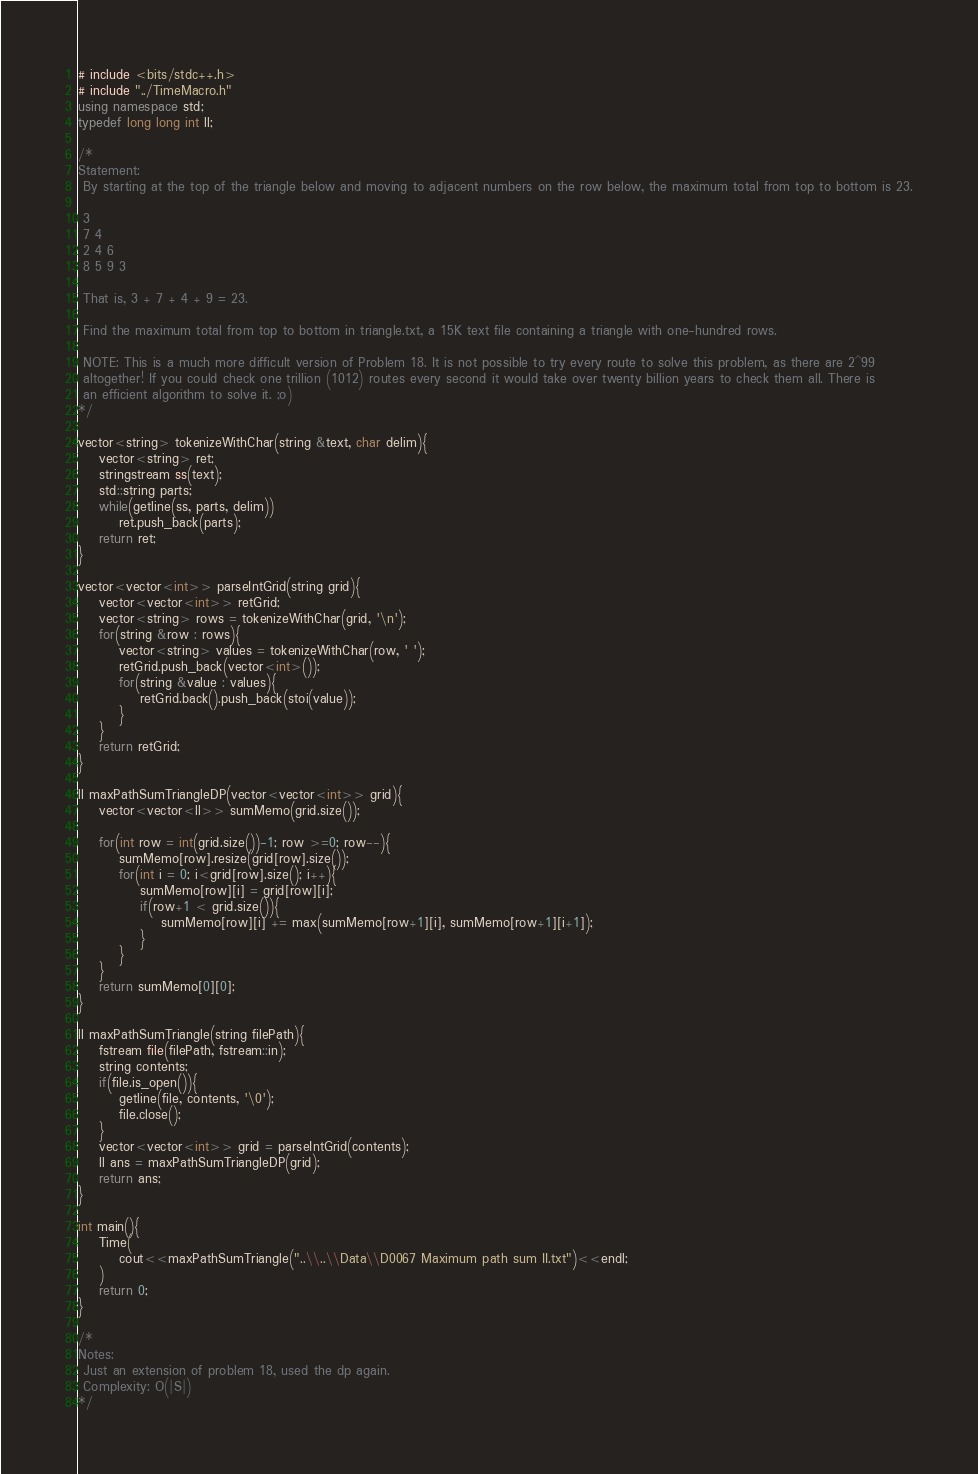<code> <loc_0><loc_0><loc_500><loc_500><_C++_># include <bits/stdc++.h>
# include "../TimeMacro.h"
using namespace std;
typedef long long int ll;

/*
Statement:
 By starting at the top of the triangle below and moving to adjacent numbers on the row below, the maximum total from top to bottom is 23.
 
 3
 7 4
 2 4 6
 8 5 9 3
 
 That is, 3 + 7 + 4 + 9 = 23.
 
 Find the maximum total from top to bottom in triangle.txt, a 15K text file containing a triangle with one-hundred rows.
 
 NOTE: This is a much more difficult version of Problem 18. It is not possible to try every route to solve this problem, as there are 2^99
 altogether! If you could check one trillion (1012) routes every second it would take over twenty billion years to check them all. There is 
 an efficient algorithm to solve it. ;o)
*/

vector<string> tokenizeWithChar(string &text, char delim){
    vector<string> ret;
    stringstream ss(text);
    std::string parts;
    while(getline(ss, parts, delim))
        ret.push_back(parts);
    return ret;
}

vector<vector<int>> parseIntGrid(string grid){
    vector<vector<int>> retGrid;
    vector<string> rows = tokenizeWithChar(grid, '\n');
    for(string &row : rows){
        vector<string> values = tokenizeWithChar(row, ' ');
        retGrid.push_back(vector<int>());
        for(string &value : values){
            retGrid.back().push_back(stoi(value));
        }
    }
    return retGrid;
}

ll maxPathSumTriangleDP(vector<vector<int>> grid){
    vector<vector<ll>> sumMemo(grid.size());
    
    for(int row = int(grid.size())-1; row >=0; row--){
        sumMemo[row].resize(grid[row].size());
        for(int i = 0; i<grid[row].size(); i++){
            sumMemo[row][i] = grid[row][i];
            if(row+1 < grid.size()){
                sumMemo[row][i] += max(sumMemo[row+1][i], sumMemo[row+1][i+1]);
            }
        }
    }
    return sumMemo[0][0];
}

ll maxPathSumTriangle(string filePath){
    fstream file(filePath, fstream::in);
    string contents;
    if(file.is_open()){
        getline(file, contents, '\0');
        file.close();
    }
    vector<vector<int>> grid = parseIntGrid(contents);
    ll ans = maxPathSumTriangleDP(grid);
    return ans;
}

int main(){
    Time(
        cout<<maxPathSumTriangle("..\\..\\Data\\D0067 Maximum path sum II.txt")<<endl;
    )
    return 0;
}

/*
Notes:
 Just an extension of problem 18, used the dp again.
 Complexity: O(|S|)
*/</code> 